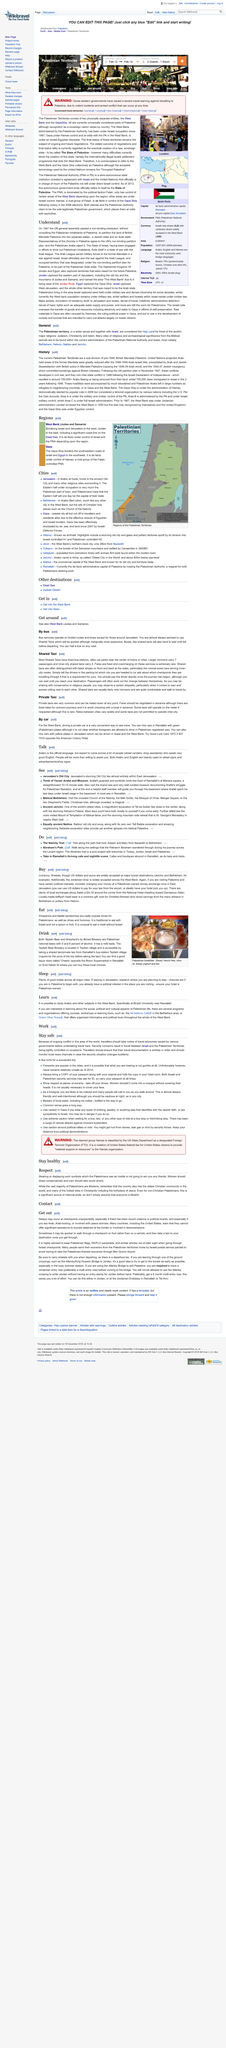Highlight a few significant elements in this photo. All Nations Café is located in the Bethlehem area, specifically where. Travelers should monitor local news channels to stay safe in Palestine. Palestine was declared unsafe in 2014. Shawarma and falafel sandwiches are widely enjoyed by Palestinians and are considered to be popular foods within their culture. The article discusses the topic of respect in relation to the Palestinian group of people. 